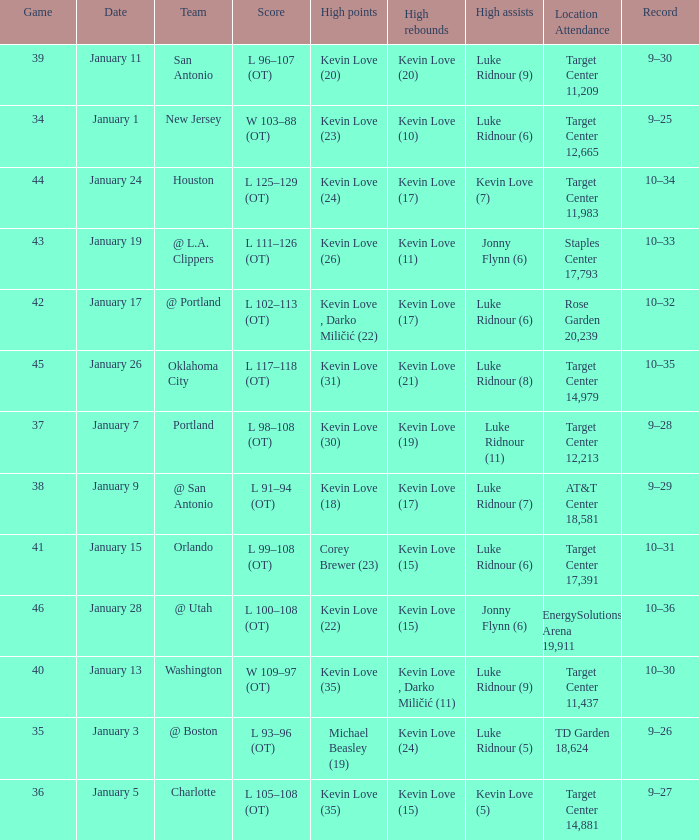For game 35, what is the scheduled date? January 3. 